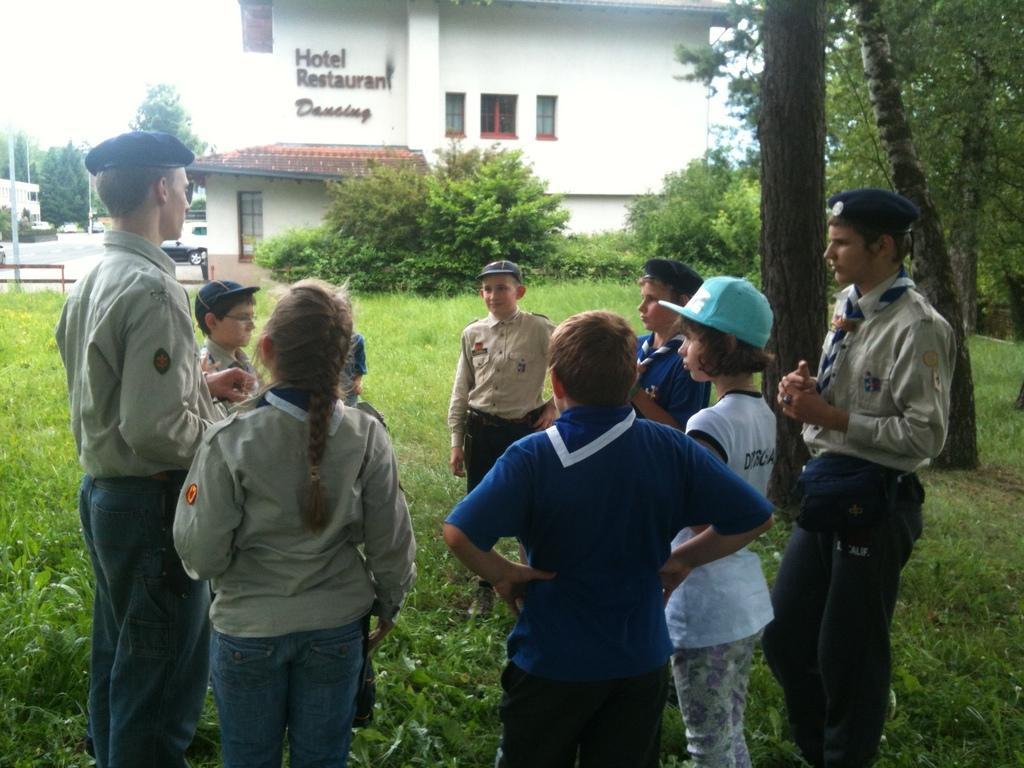Please provide a concise description of this image. In this image there are a few people standing on the surface of the grass. In the background there is a building and trees. 